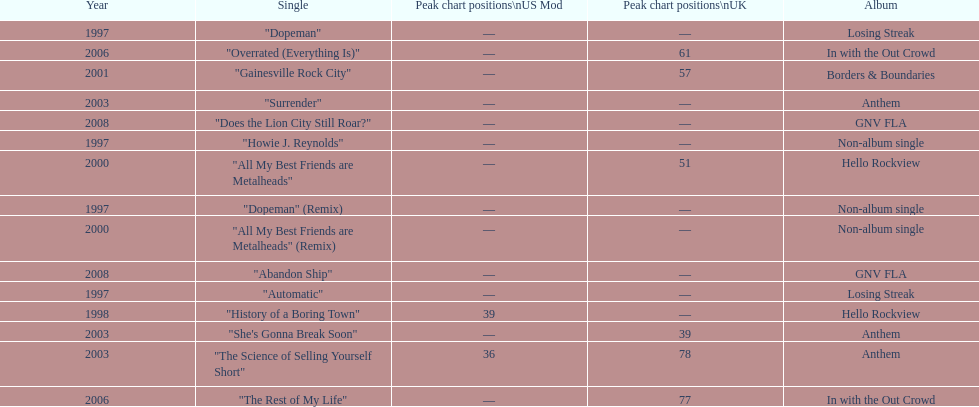Name one other single that was on the losing streak album besides "dopeman". "Automatic". 